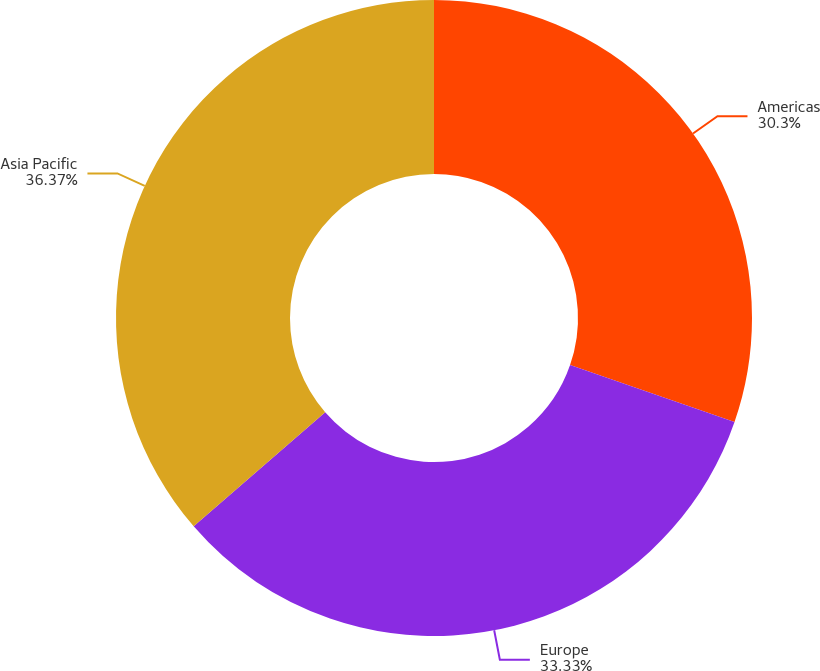Convert chart. <chart><loc_0><loc_0><loc_500><loc_500><pie_chart><fcel>Americas<fcel>Europe<fcel>Asia Pacific<nl><fcel>30.3%<fcel>33.33%<fcel>36.36%<nl></chart> 